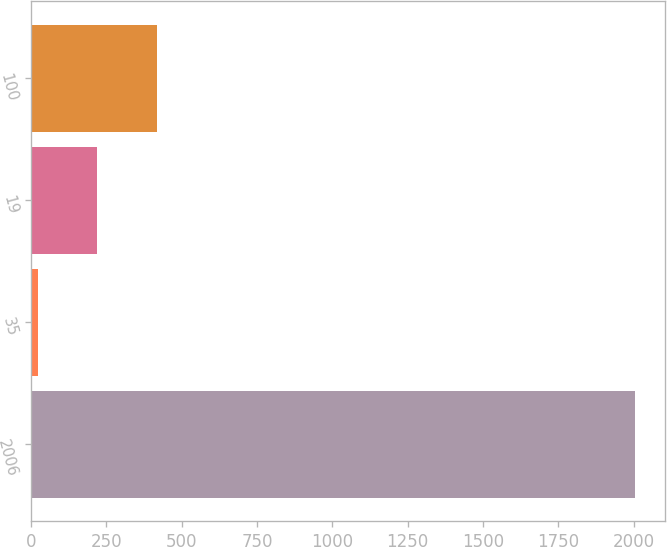Convert chart. <chart><loc_0><loc_0><loc_500><loc_500><bar_chart><fcel>2006<fcel>35<fcel>19<fcel>100<nl><fcel>2005<fcel>21<fcel>219.4<fcel>417.8<nl></chart> 